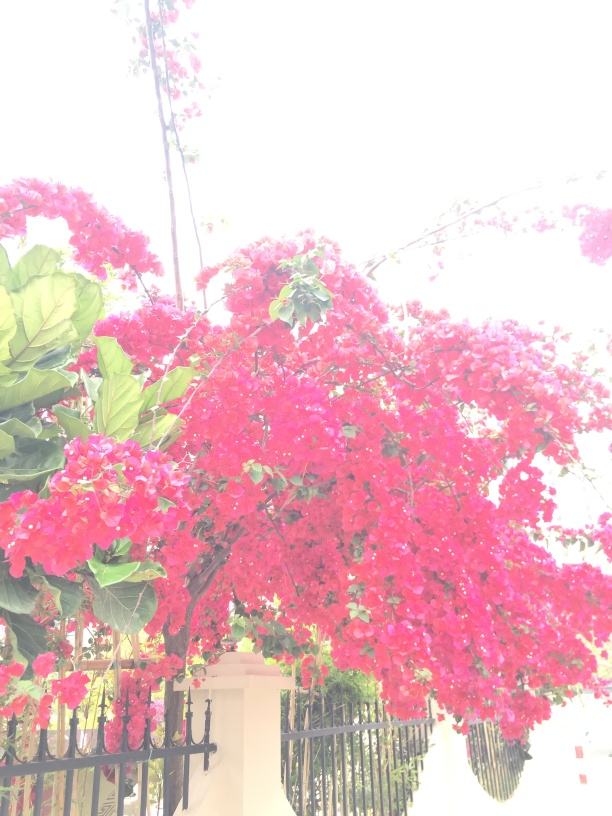How would you describe the overall clarity of this image? The image exhibits a degree of overexposure, particularly in the background areas where detail is lost, thus giving it an overall clarity that is somewhat compromised. The vivid red flowers in the foreground, however, are still distinguishable, but the image could benefit from better lighting balance to enhance clarity. 